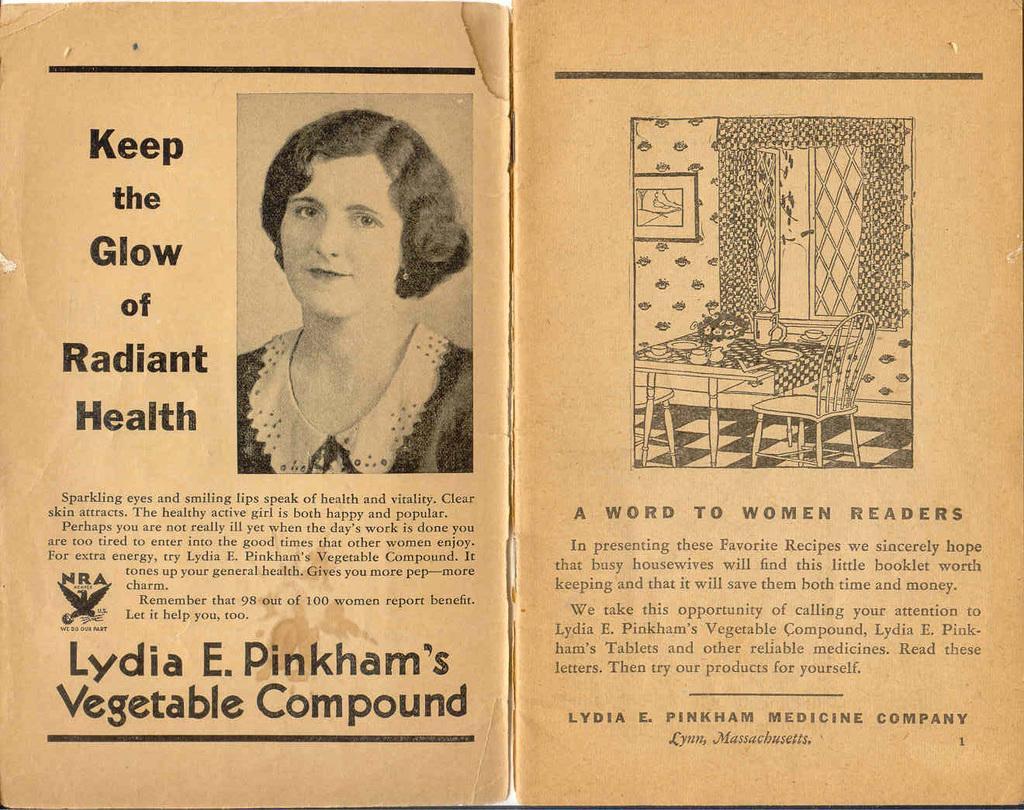In one or two sentences, can you explain what this image depicts? It is a poster. In this image there is a depiction of a person. There is a table. On top of it there are some objects. There are chairs. In the background of the image there is a photo frame on the wall. There is a window. There is some text on the image. 